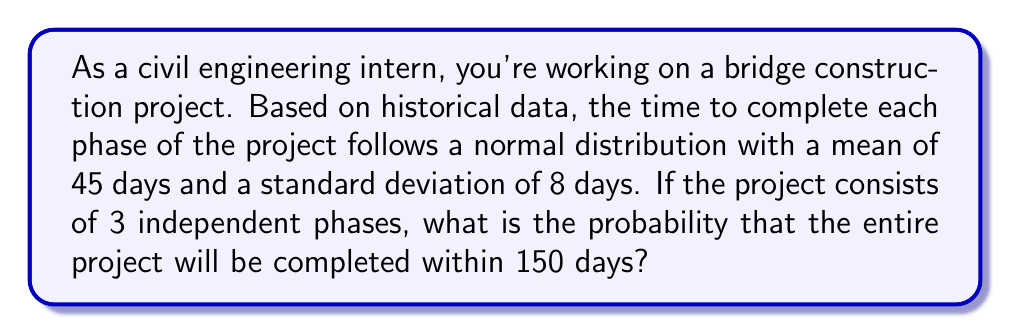What is the answer to this math problem? Let's approach this step-by-step:

1) First, we need to find the total mean and standard deviation for the entire project:

   Mean for entire project: $\mu_{total} = 3 * 45 = 135$ days
   
   Since the phases are independent, we can use the property of variances:
   $\sigma_{total}^2 = 3 * \sigma^2$
   $\sigma_{total} = \sqrt{3 * 8^2} = \sqrt{192} = 13.86$ days

2) Now, we want to find $P(X \leq 150)$ where $X$ is the total project time.

3) We can standardize this to a Z-score:

   $Z = \frac{X - \mu}{\sigma} = \frac{150 - 135}{13.86} = 1.08$

4) Now we need to find $P(Z \leq 1.08)$ using a standard normal distribution table or calculator.

5) Using a standard normal table or calculator, we find:

   $P(Z \leq 1.08) \approx 0.8599$

Therefore, the probability of completing the project within 150 days is approximately 0.8599 or 85.99%.
Answer: $0.8599$ or $85.99\%$ 